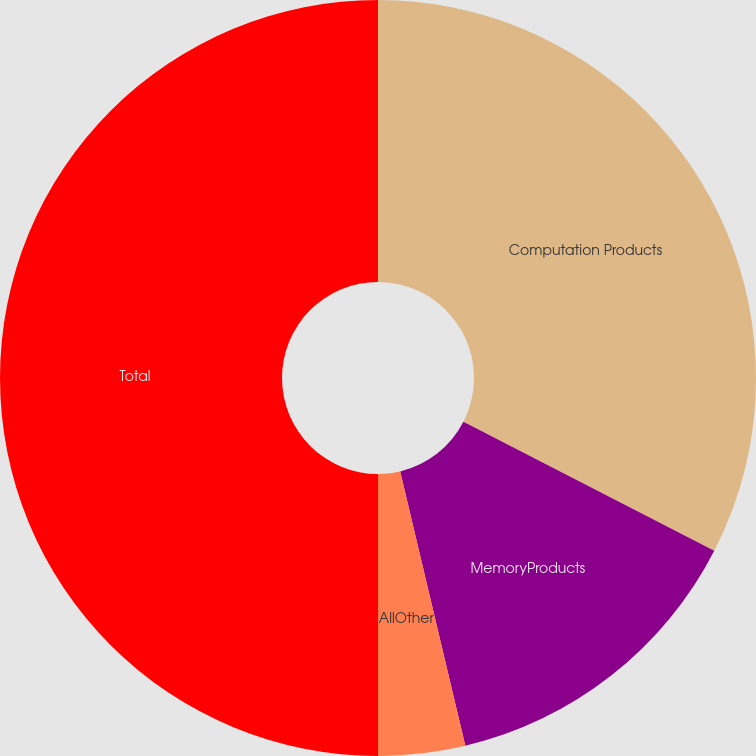<chart> <loc_0><loc_0><loc_500><loc_500><pie_chart><fcel>Computation Products<fcel>MemoryProducts<fcel>AllOther<fcel>Total<nl><fcel>32.55%<fcel>13.74%<fcel>3.71%<fcel>50.0%<nl></chart> 